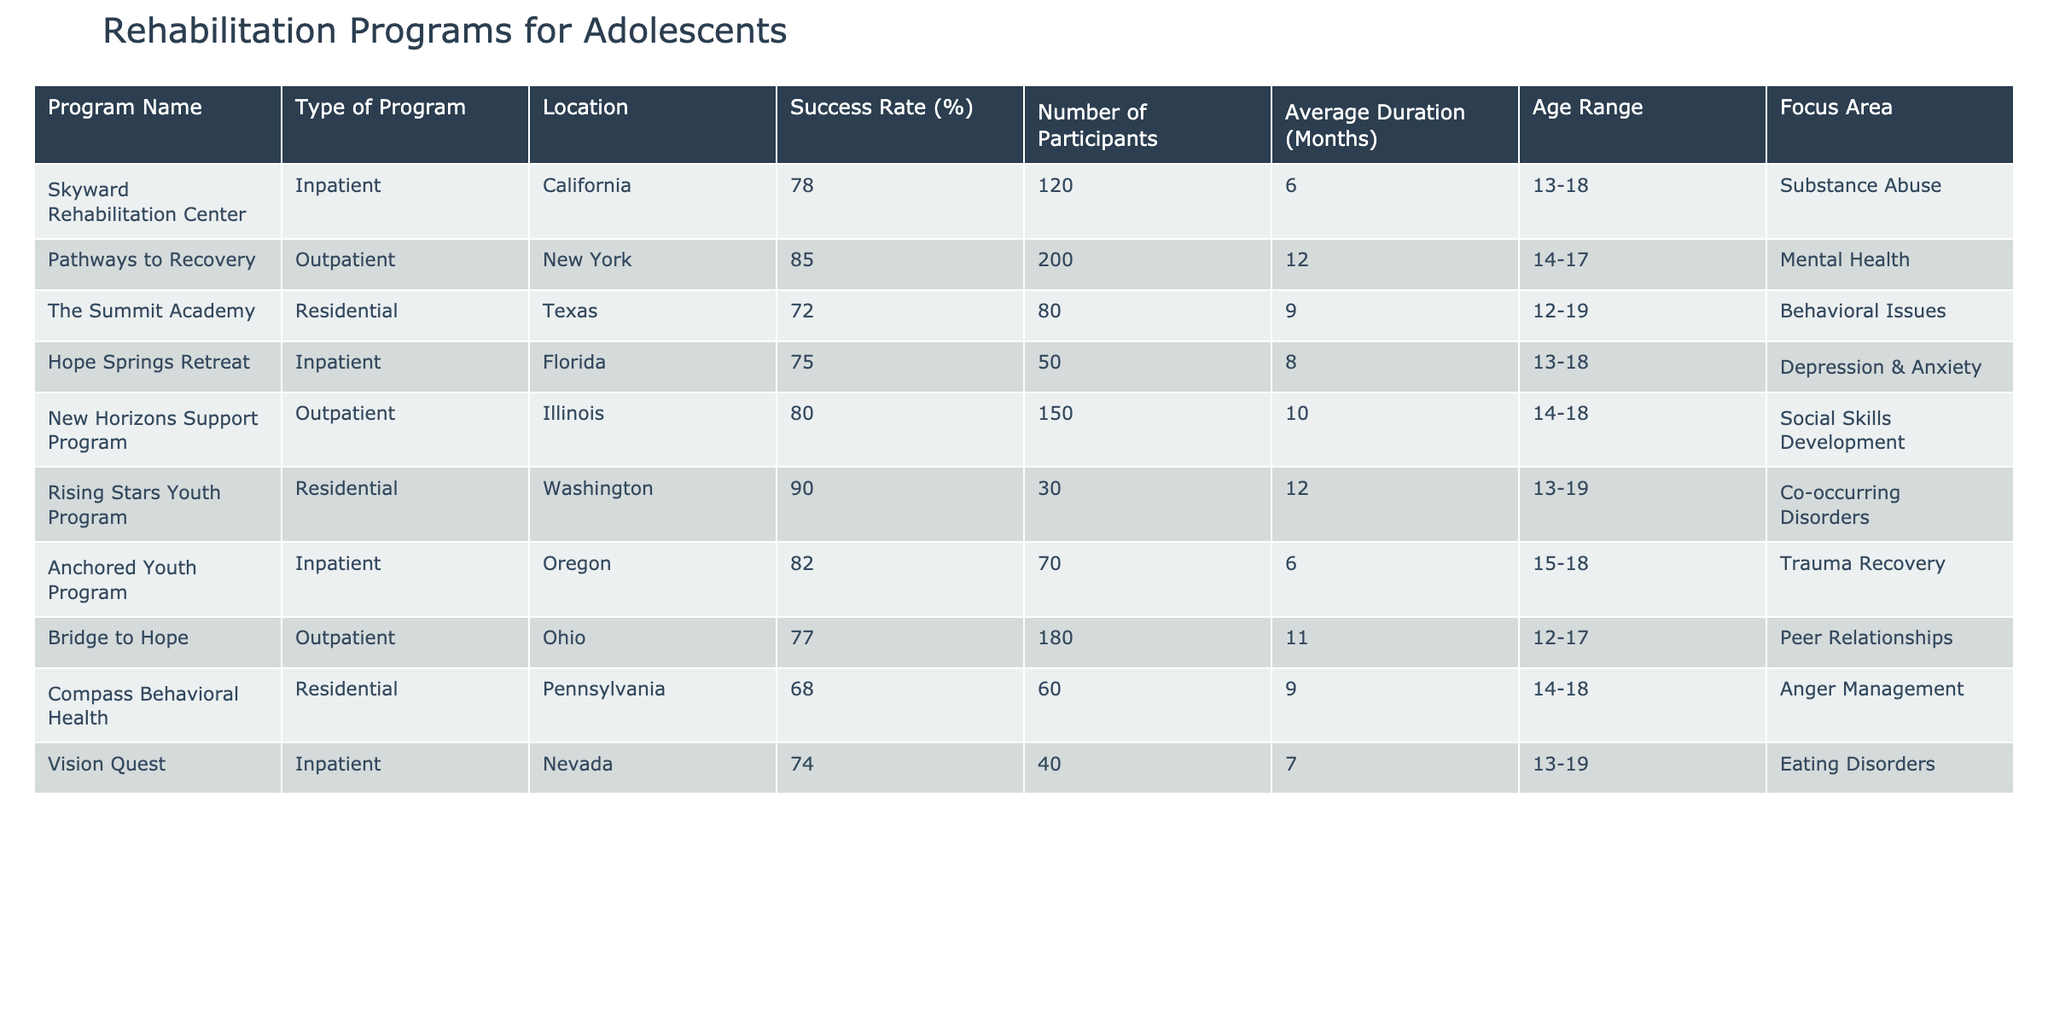What is the highest success rate among the programs listed? By reviewing the success rates in the table, Rising Stars Youth Program has the highest success rate at 90%.
Answer: 90% How many participants did the Pathways to Recovery program have? The Pathways to Recovery program has 200 participants listed in the table.
Answer: 200 Which program focuses on eating disorders and what is its success rate? The Vision Quest program focuses on eating disorders and has a success rate of 74%.
Answer: Vision Quest, 74% What is the average success rate of the outpatient programs? There are three outpatient programs with success rates of 85%, 80%, and 77%. The sum is 85 + 80 + 77 = 242, and the average is 242/3 = 80.67%.
Answer: 80.67% Does the Compass Behavioral Health program have a success rate higher than 70%? The Compass Behavioral Health program has a success rate of 68%, which is not higher than 70%.
Answer: No Which type of program has the lowest success rate? By examining the table, Compass Behavioral Health as a residential program has the lowest success rate of 68%.
Answer: Residential How many inpatient programs have a success rate above 75%? There are three inpatient programs: Skyward Rehabilitation Center (78%), Hope Springs Retreat (75%), and Anchored Youth Program (82%). Only Skyward and Anchored exceed 75%.
Answer: 2 Which program has the longest average duration and what is that duration? The Pathways to Recovery program has the longest average duration of 12 months among the listed programs.
Answer: 12 months What is the age range of participants in the Rising Stars Youth Program? The age range for the Rising Stars Youth Program participants is 13-19 years old.
Answer: 13-19 What is the difference in success rates between the highest and lowest programs? Rising Stars Youth has the highest at 90% and Compass Behavioral Health the lowest at 68%. The difference is 90% - 68% = 22%.
Answer: 22% 